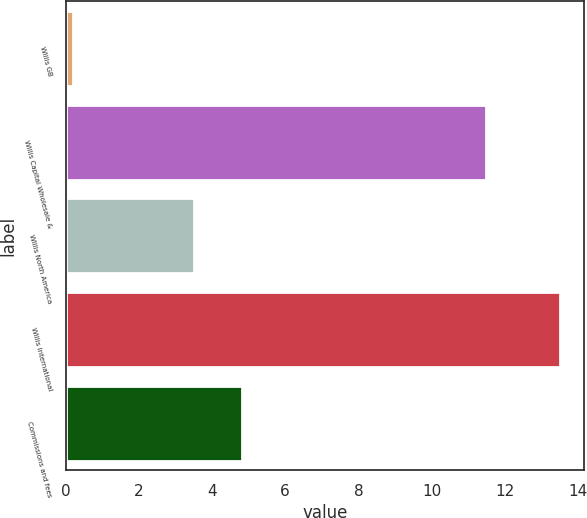<chart> <loc_0><loc_0><loc_500><loc_500><bar_chart><fcel>Willis GB<fcel>Willis Capital Wholesale &<fcel>Willis North America<fcel>Willis International<fcel>Commissions and fees<nl><fcel>0.2<fcel>11.5<fcel>3.5<fcel>13.5<fcel>4.83<nl></chart> 